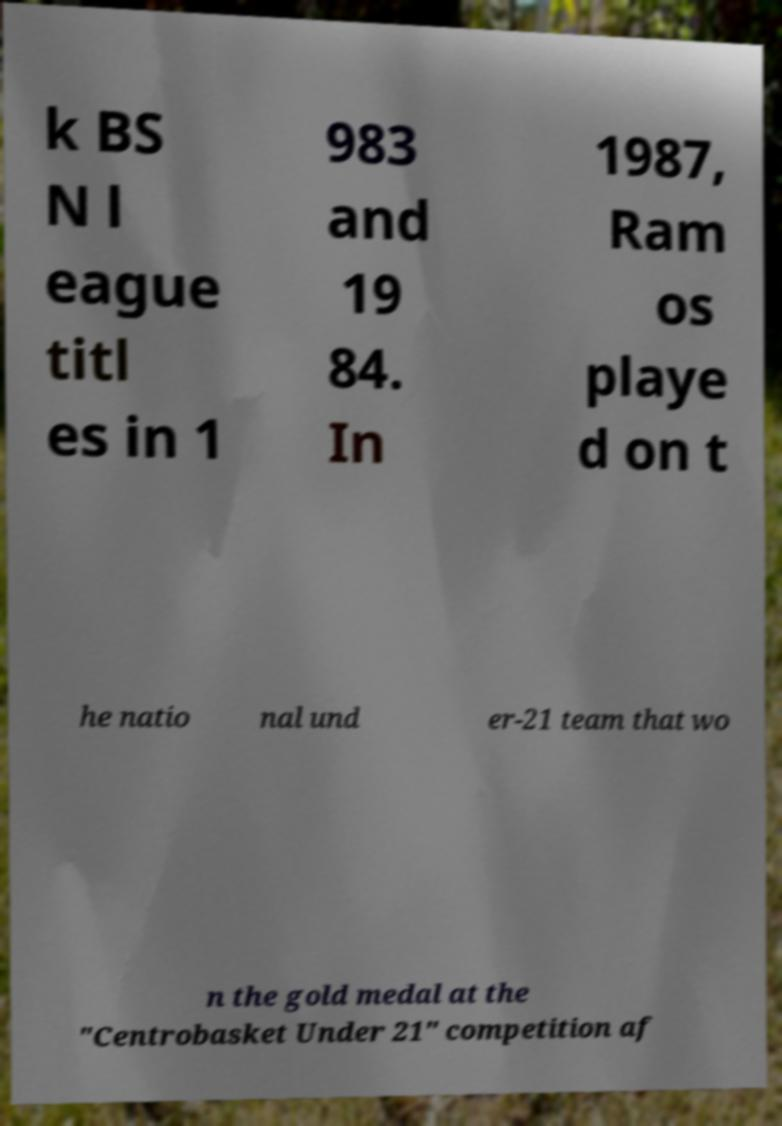There's text embedded in this image that I need extracted. Can you transcribe it verbatim? k BS N l eague titl es in 1 983 and 19 84. In 1987, Ram os playe d on t he natio nal und er-21 team that wo n the gold medal at the "Centrobasket Under 21" competition af 